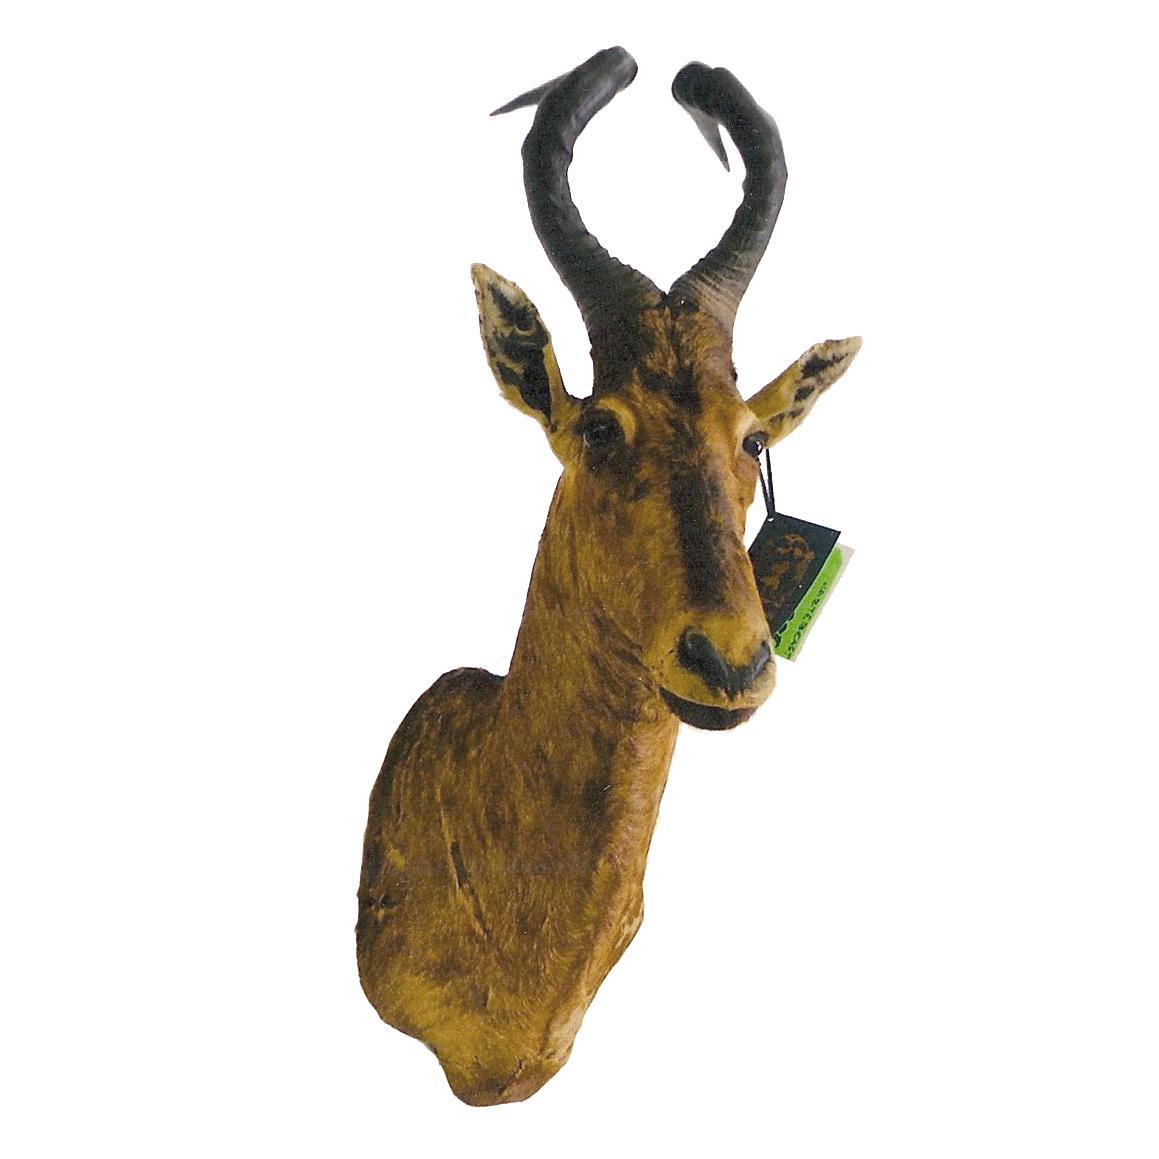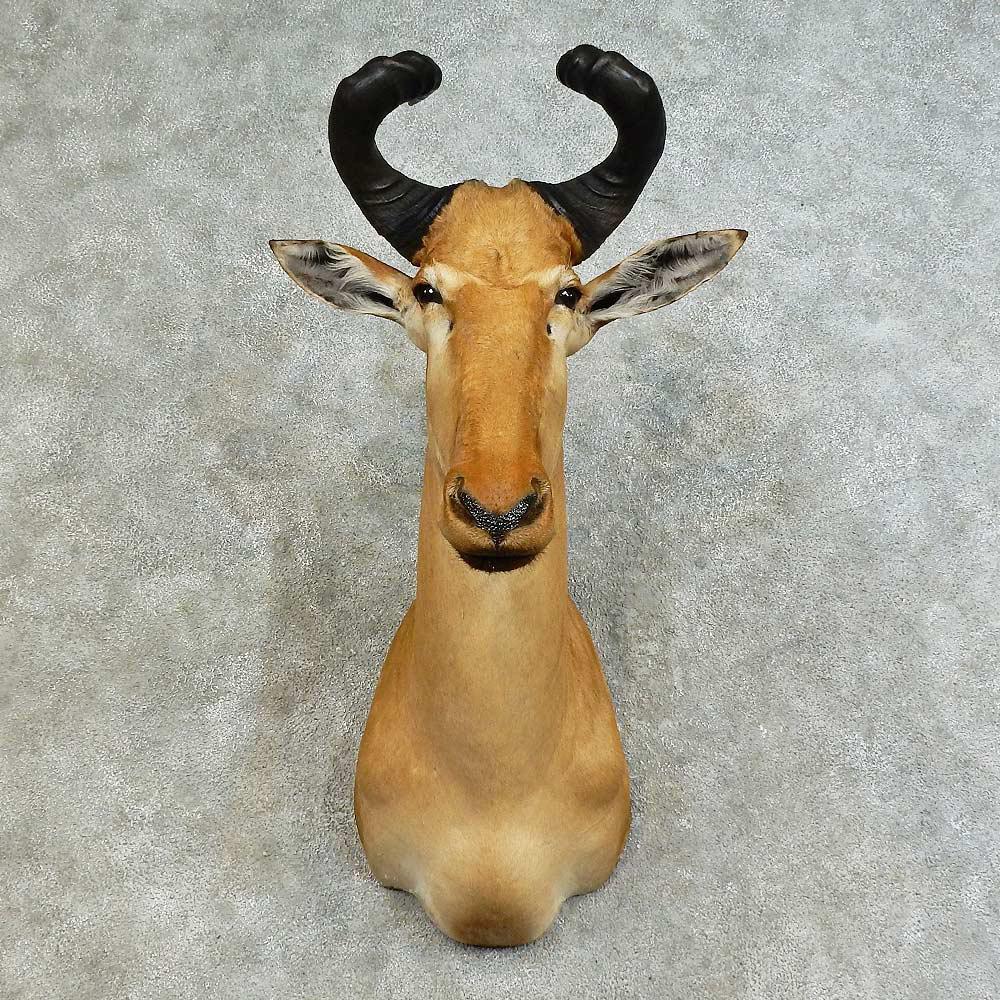The first image is the image on the left, the second image is the image on the right. Assess this claim about the two images: "An image shows the head of a horned animal mounted on a knotty wood plank wall.". Correct or not? Answer yes or no. No. The first image is the image on the left, the second image is the image on the right. Given the left and right images, does the statement "There are two antelope heads shown without a body." hold true? Answer yes or no. Yes. 